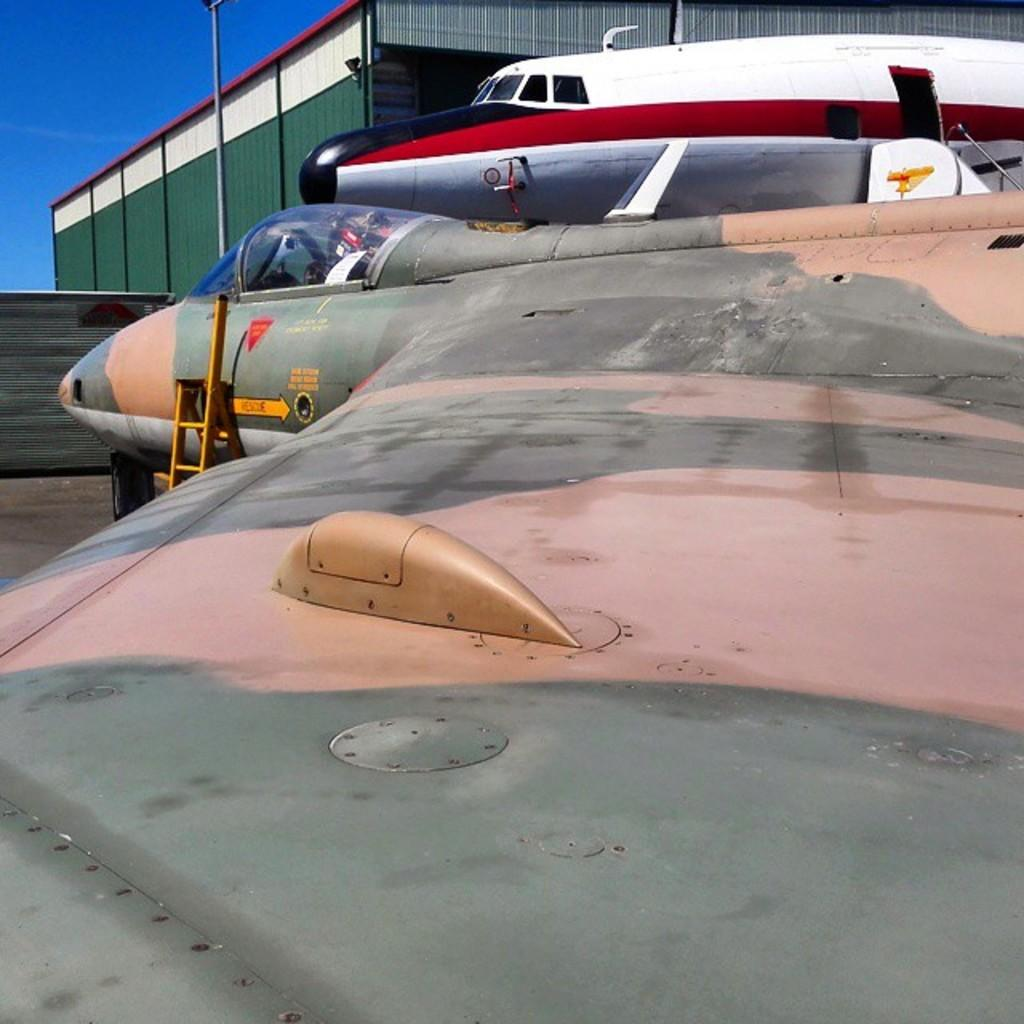What is the main subject of the picture? The main subject of the picture is aircrafts. What structure can be seen behind the aircrafts? There is a shed behind the aircrafts the aircrafts. What object is located near the aircrafts? There is a pole near the aircrafts. What can be seen in the background of the picture? The sky is visible in the background of the picture. What thought is the aircraft having in the picture? Aircrafts do not have thoughts, as they are inanimate objects. What rule is being enforced by the aircraft in the picture? Aircrafts do not enforce rules, as they are inanimate objects. 